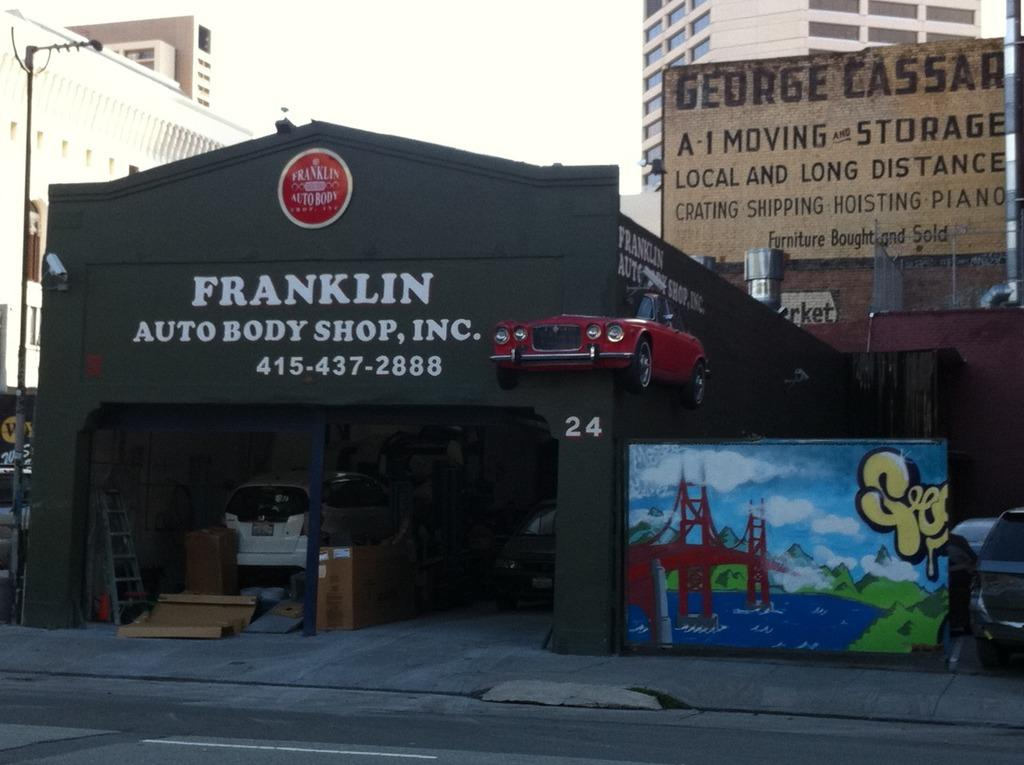<image>
Create a compact narrative representing the image presented. Franklin Auto Body Shop storefront next to George Cassar Moving and Storage 